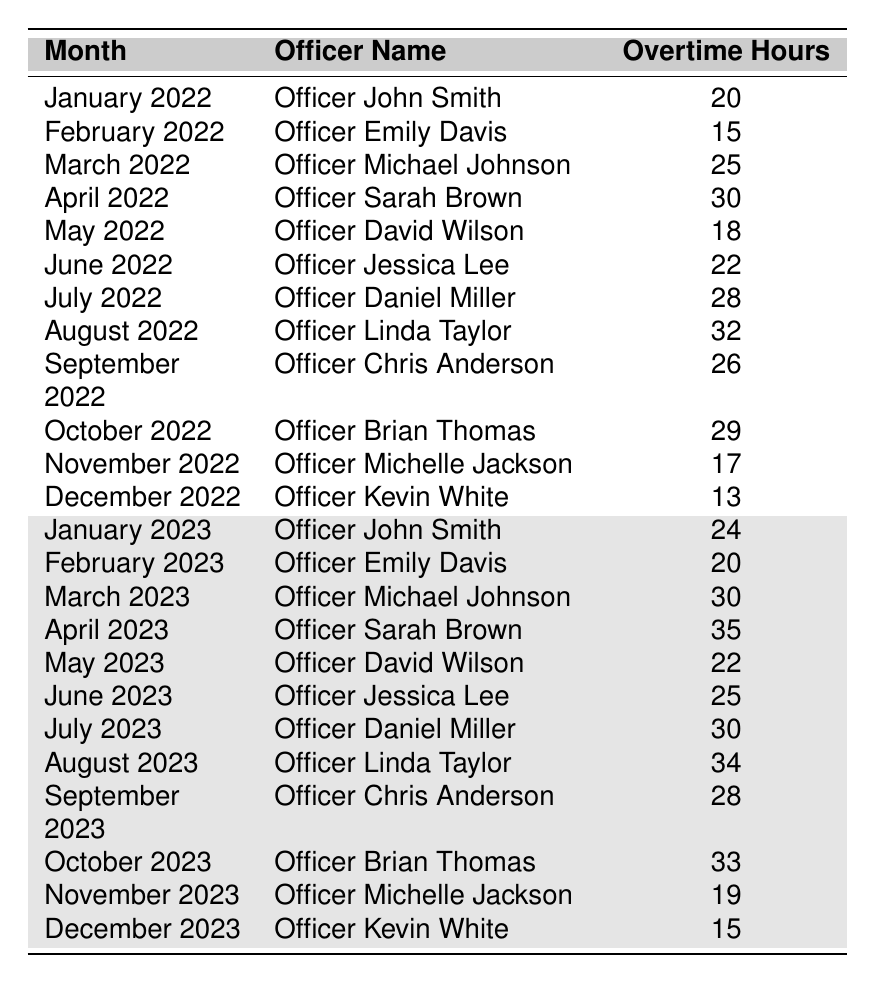What's the total overtime hours logged by Officer John Smith over the two years? Officer John Smith's overtime hours are logged for January 2022 (20 hours) and January 2023 (24 hours). Adding these two values gives 20 + 24 = 44 hours.
Answer: 44 hours Which month had the highest recorded overtime and who was the officer? The highest recorded overtime is 35 hours in April 2023, and the officer was Sarah Brown.
Answer: April 2023, Officer Sarah Brown How many officers logged more than 30 hours in any month during the two years? Analyzing the table, the officers and months are: Officer Sarah Brown in April 2023 (35 hours), Officer Linda Taylor in August 2023 (34 hours), Officer Brian Thomas in October 2023 (33 hours), and Officer Linda Taylor in August 2022 (32 hours). That totals 4 instances.
Answer: 4 instances What was the total overtime hours for all officers in December of both years? In December 2022, Kevin White logged 13 hours, and in December 2023, he logged 15 hours. Summing these gives 13 + 15 = 28 hours for both December months.
Answer: 28 hours Did Officer Michelle Jackson have more overtime hours logged in 2023 compared to 2022? In 2022, Officer Michelle Jackson had 17 hours in November; in 2023, she logged 19 hours in November. Since 19 > 17, it's true she had more.
Answer: Yes What is the average overtime hours logged by Officer Jessica Lee over the reported months? Officer Jessica Lee logged 22 hours in June 2022 and 25 hours in June 2023. To find the average: (22 + 25) / 2 = 23.5 hours.
Answer: 23.5 hours Which officer had the least overtime hours in a single month and in which month was it logged? The smallest value in the table is 13 hours logged by Officer Kevin White in December 2022.
Answer: Officer Kevin White, December 2022 If we sum all overtime hours for the entire data, what is the total? Summing all the overtime hours listed in the table (20 + 15 + 25 + 30 + 18 + 22 + 28 + 32 + 26 + 29 + 17 + 13 + 24 + 20 + 30 + 35 + 22 + 25 + 30 + 34 + 28 + 33 + 19 + 15) leads to a total of 575 hours.
Answer: 575 hours How many months show an increase in overtime from the same month in the prior year? Comparing each month to the same month in the previous year, the months showing an increase are January, March, April, May, June, July, August, September, October, and November. That's 10 months with increases.
Answer: 10 months Who's the officer with the highest total overtime across the two years and what is their total? Adding up all the reported overtime hours, Officer Sarah Brown has 30 hours (April 2022) and 35 hours (April 2023) totaling 65 hours; that's the highest total for any officer.
Answer: Officer Sarah Brown, 65 hours 